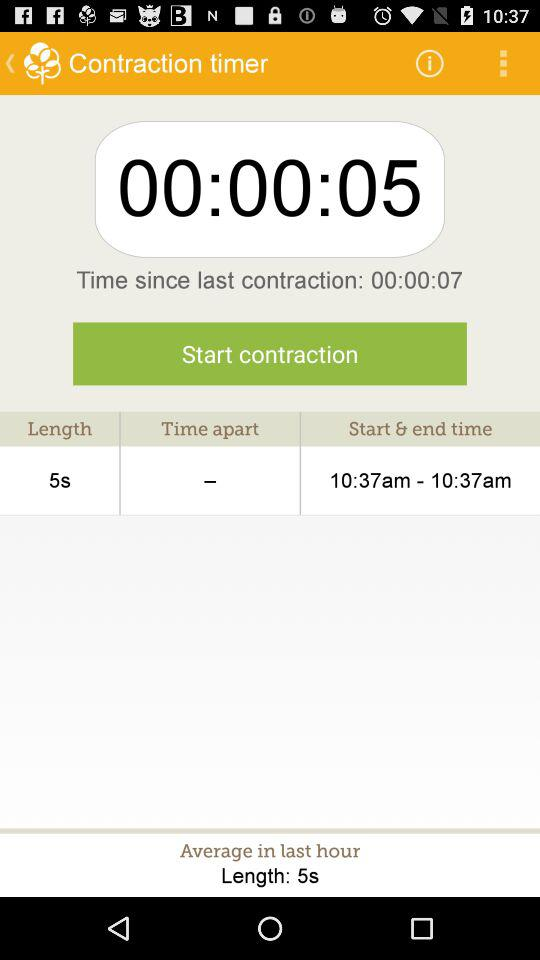What is the start and end time? The start and end times are 10:37 am and 10:37 am. 